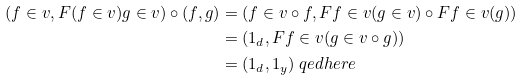<formula> <loc_0><loc_0><loc_500><loc_500>( f \in v , F ( f \in v ) g \in v ) \circ ( f , g ) & = ( f \in v \circ f , F f \in v ( g \in v ) \circ F f \in v ( g ) ) \\ & = ( 1 _ { d } , F f \in v ( g \in v \circ g ) ) \\ & = ( 1 _ { d } , 1 _ { y } ) \ q e d h e r e</formula> 